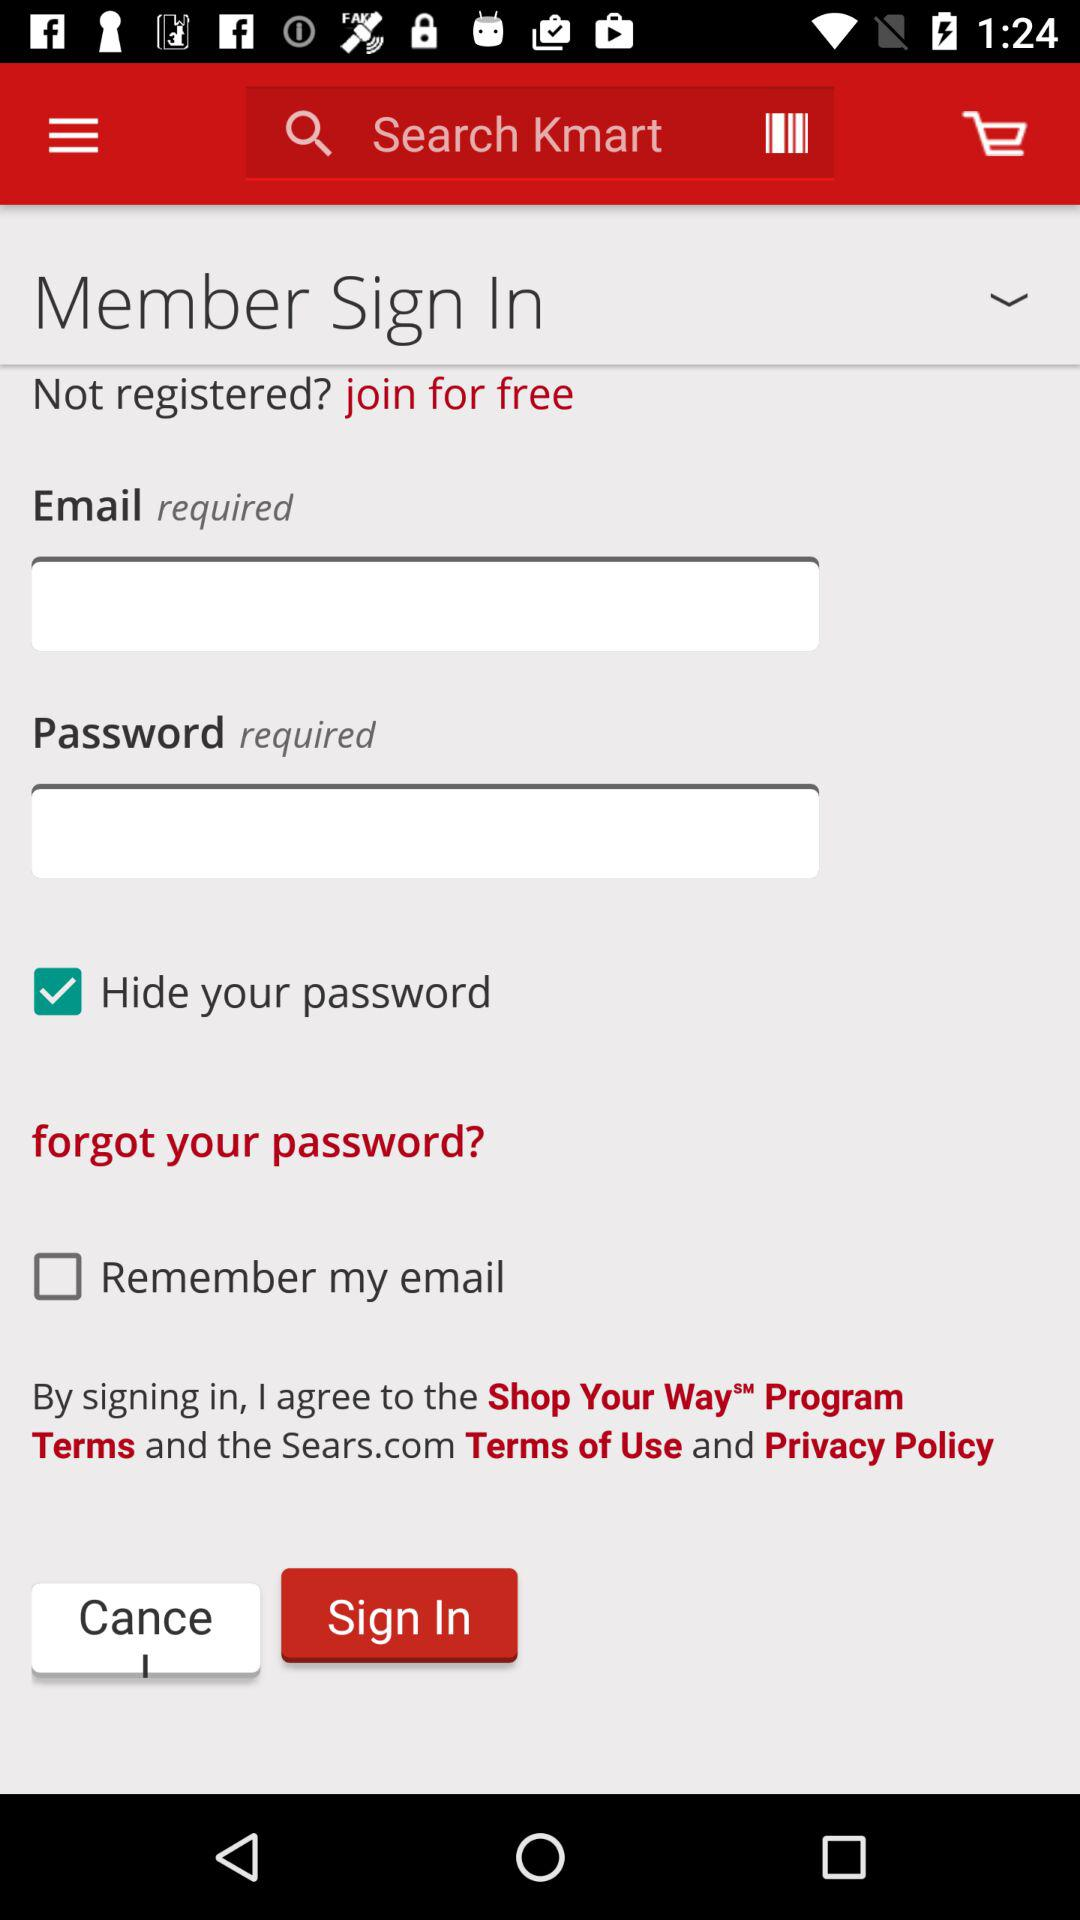How many text inputs are required?
Answer the question using a single word or phrase. 2 